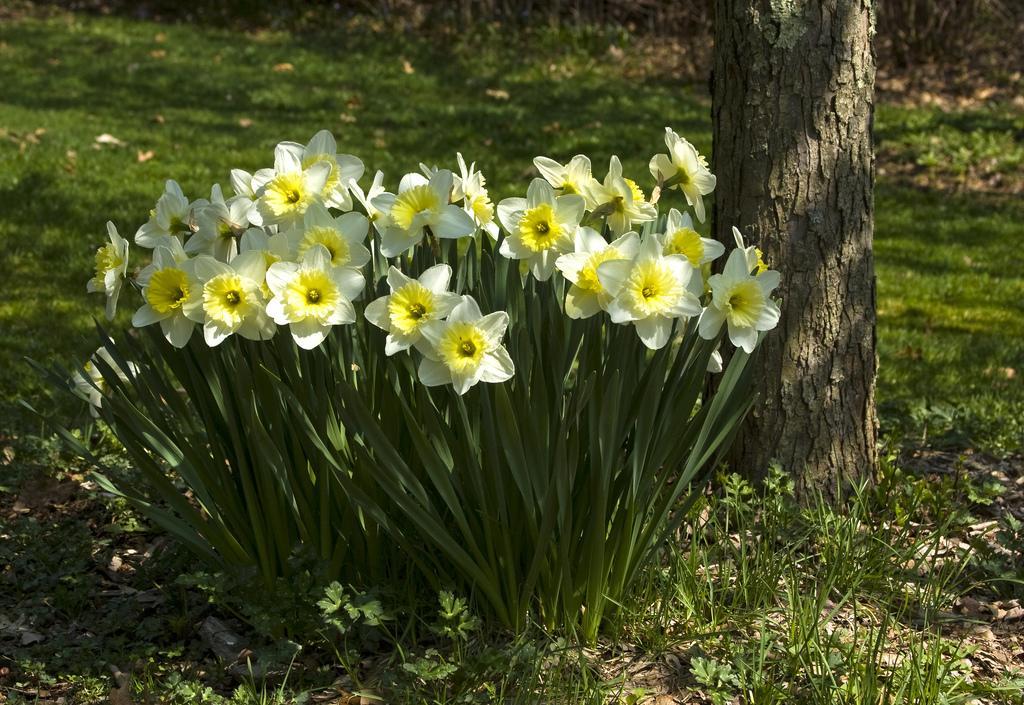Describe this image in one or two sentences. In this image we can see the yellow flowers. Here we can see the trunk of a tree on the right side. Here we can see the grass all over. 